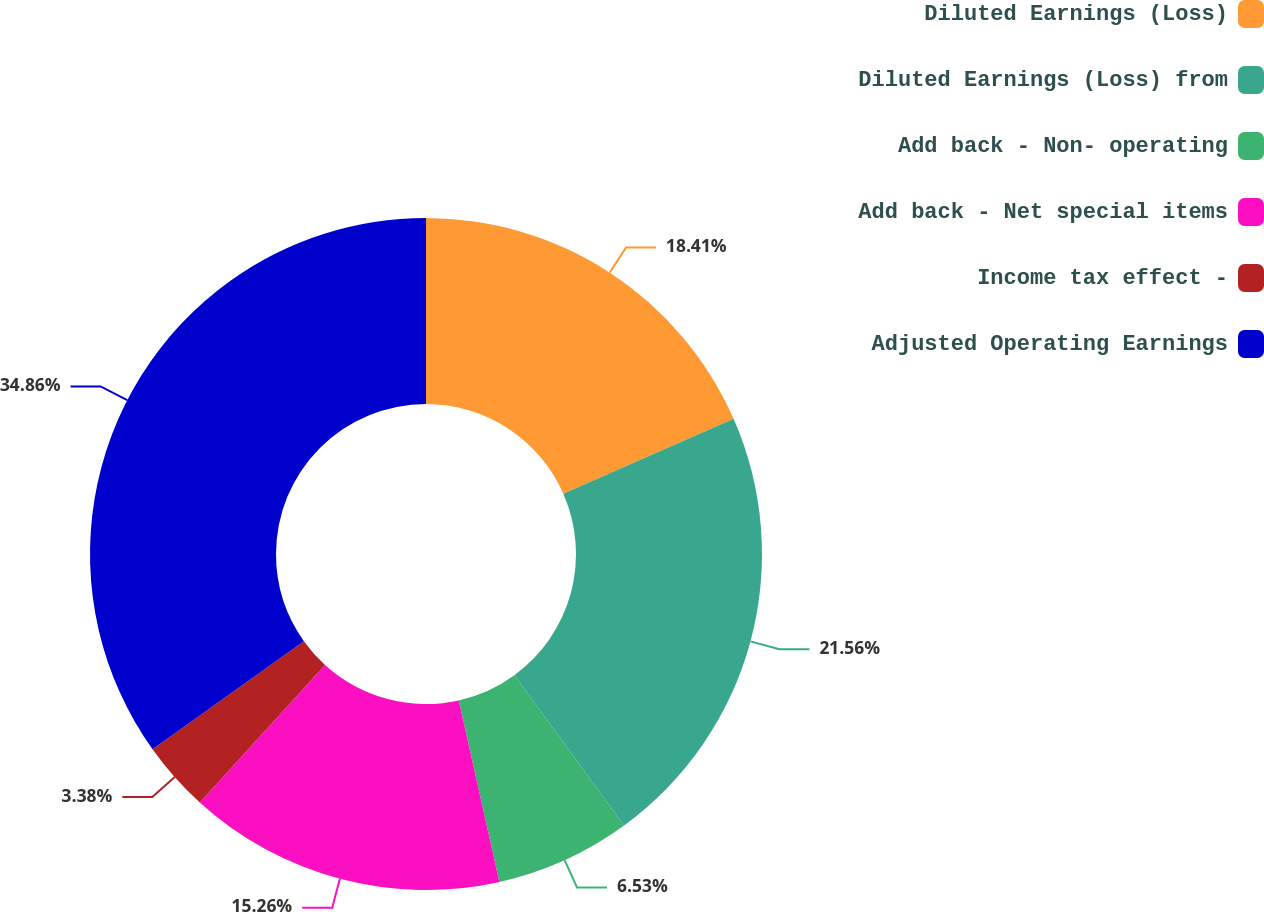Convert chart to OTSL. <chart><loc_0><loc_0><loc_500><loc_500><pie_chart><fcel>Diluted Earnings (Loss)<fcel>Diluted Earnings (Loss) from<fcel>Add back - Non- operating<fcel>Add back - Net special items<fcel>Income tax effect -<fcel>Adjusted Operating Earnings<nl><fcel>18.41%<fcel>21.56%<fcel>6.53%<fcel>15.26%<fcel>3.38%<fcel>34.87%<nl></chart> 